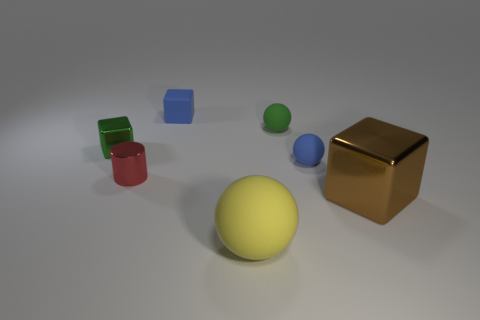What size is the ball that is the same color as the small shiny block?
Offer a very short reply. Small. Is the material of the tiny green ball the same as the green block?
Your answer should be very brief. No. Is the number of large spheres less than the number of large blue matte blocks?
Your answer should be very brief. No. Does the big brown shiny object have the same shape as the big yellow rubber object?
Offer a very short reply. No. What is the color of the shiny cylinder?
Your answer should be very brief. Red. How many other things are made of the same material as the yellow object?
Provide a succinct answer. 3. How many brown objects are either blocks or tiny rubber things?
Provide a short and direct response. 1. Is the shape of the shiny object that is on the left side of the red shiny cylinder the same as the small blue matte object on the right side of the tiny green rubber ball?
Offer a very short reply. No. Does the metal cylinder have the same color as the shiny cube that is to the left of the small green matte ball?
Your response must be concise. No. Do the large thing behind the large yellow rubber thing and the small metallic cube have the same color?
Your answer should be very brief. No. 